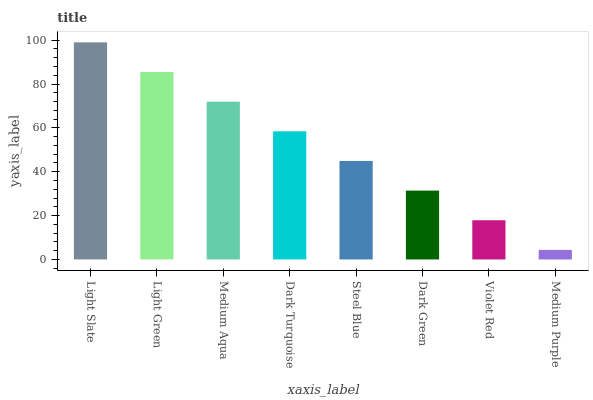Is Light Green the minimum?
Answer yes or no. No. Is Light Green the maximum?
Answer yes or no. No. Is Light Slate greater than Light Green?
Answer yes or no. Yes. Is Light Green less than Light Slate?
Answer yes or no. Yes. Is Light Green greater than Light Slate?
Answer yes or no. No. Is Light Slate less than Light Green?
Answer yes or no. No. Is Dark Turquoise the high median?
Answer yes or no. Yes. Is Steel Blue the low median?
Answer yes or no. Yes. Is Light Green the high median?
Answer yes or no. No. Is Dark Turquoise the low median?
Answer yes or no. No. 